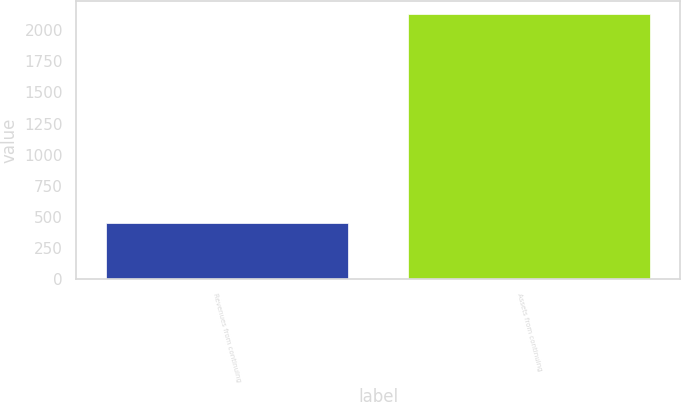Convert chart to OTSL. <chart><loc_0><loc_0><loc_500><loc_500><bar_chart><fcel>Revenues from continuing<fcel>Assets from continuing<nl><fcel>447.5<fcel>2130.5<nl></chart> 